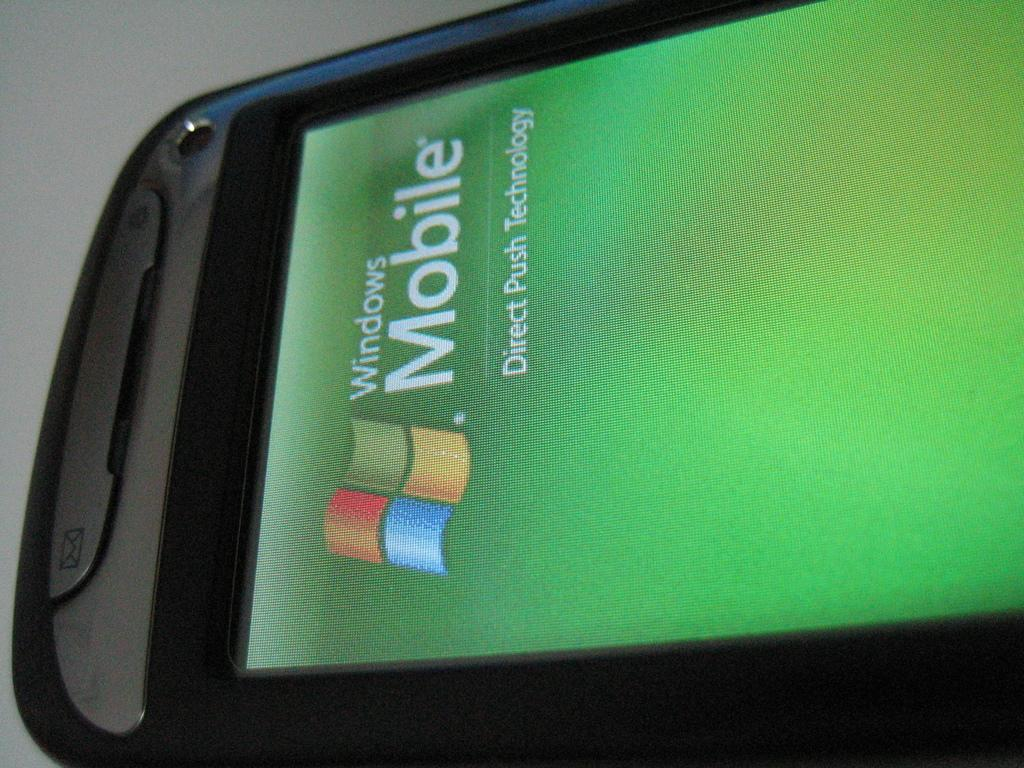<image>
Provide a brief description of the given image. A  smartphone displys Home page for Windows mobile, "Direct Push Technology" 